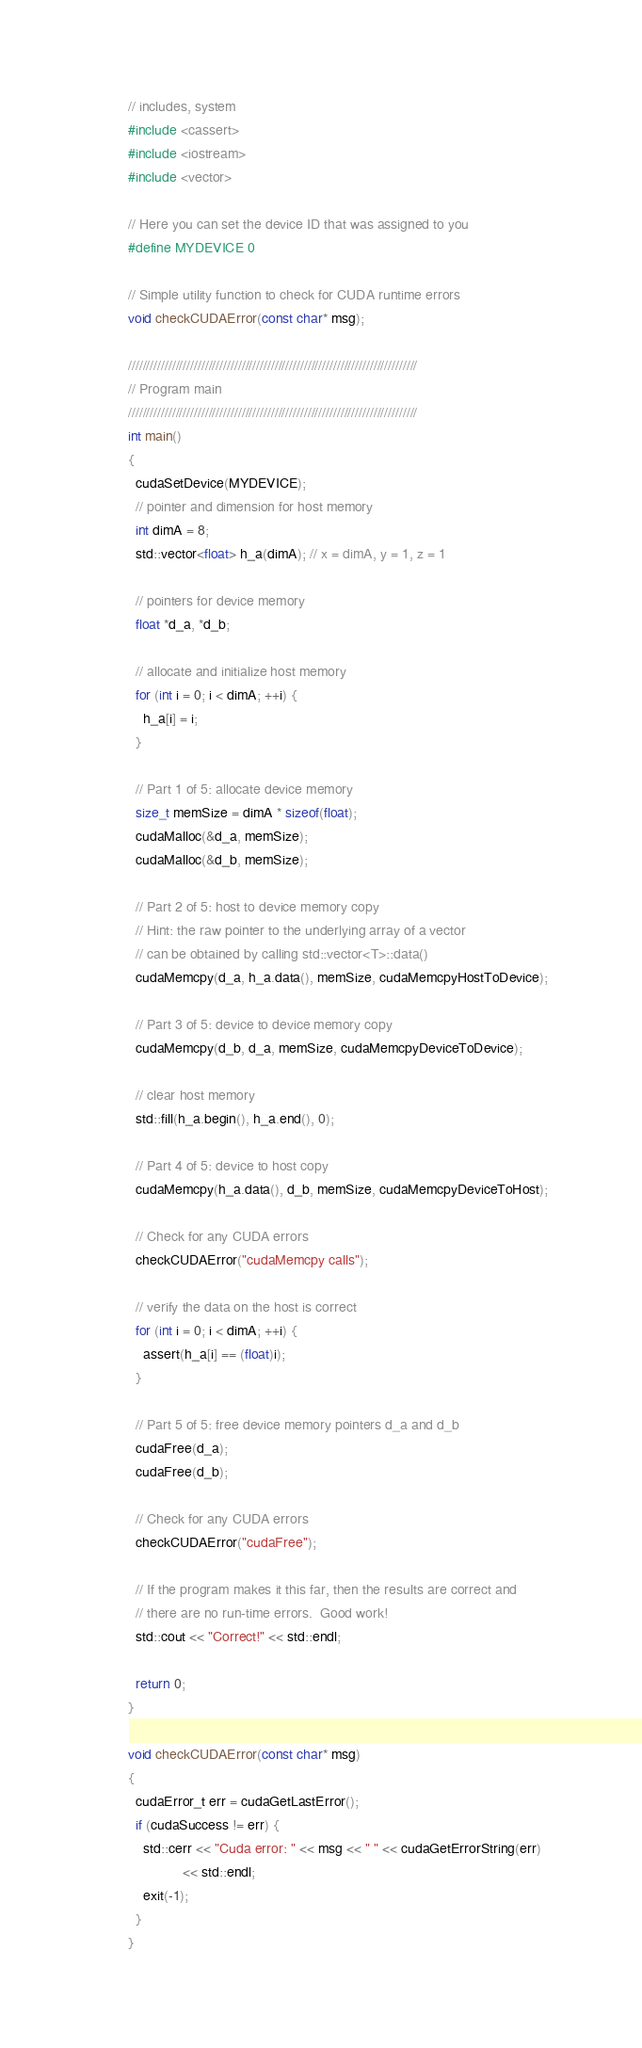Convert code to text. <code><loc_0><loc_0><loc_500><loc_500><_Cuda_>// includes, system
#include <cassert>
#include <iostream>
#include <vector>

// Here you can set the device ID that was assigned to you
#define MYDEVICE 0

// Simple utility function to check for CUDA runtime errors
void checkCUDAError(const char* msg);

///////////////////////////////////////////////////////////////////////////////
// Program main
///////////////////////////////////////////////////////////////////////////////
int main()
{
  cudaSetDevice(MYDEVICE);
  // pointer and dimension for host memory
  int dimA = 8;
  std::vector<float> h_a(dimA); // x = dimA, y = 1, z = 1

  // pointers for device memory
  float *d_a, *d_b;

  // allocate and initialize host memory
  for (int i = 0; i < dimA; ++i) {
    h_a[i] = i;
  }

  // Part 1 of 5: allocate device memory
  size_t memSize = dimA * sizeof(float);
  cudaMalloc(&d_a, memSize);
  cudaMalloc(&d_b, memSize);

  // Part 2 of 5: host to device memory copy
  // Hint: the raw pointer to the underlying array of a vector
  // can be obtained by calling std::vector<T>::data()
  cudaMemcpy(d_a, h_a.data(), memSize, cudaMemcpyHostToDevice);

  // Part 3 of 5: device to device memory copy
  cudaMemcpy(d_b, d_a, memSize, cudaMemcpyDeviceToDevice);

  // clear host memory
  std::fill(h_a.begin(), h_a.end(), 0);

  // Part 4 of 5: device to host copy
  cudaMemcpy(h_a.data(), d_b, memSize, cudaMemcpyDeviceToHost);

  // Check for any CUDA errors
  checkCUDAError("cudaMemcpy calls");

  // verify the data on the host is correct
  for (int i = 0; i < dimA; ++i) {
    assert(h_a[i] == (float)i);
  }

  // Part 5 of 5: free device memory pointers d_a and d_b
  cudaFree(d_a);
  cudaFree(d_b);

  // Check for any CUDA errors
  checkCUDAError("cudaFree");

  // If the program makes it this far, then the results are correct and
  // there are no run-time errors.  Good work!
  std::cout << "Correct!" << std::endl;

  return 0;
}

void checkCUDAError(const char* msg)
{
  cudaError_t err = cudaGetLastError();
  if (cudaSuccess != err) {
    std::cerr << "Cuda error: " << msg << " " << cudaGetErrorString(err)
              << std::endl;
    exit(-1);
  }
}
</code> 